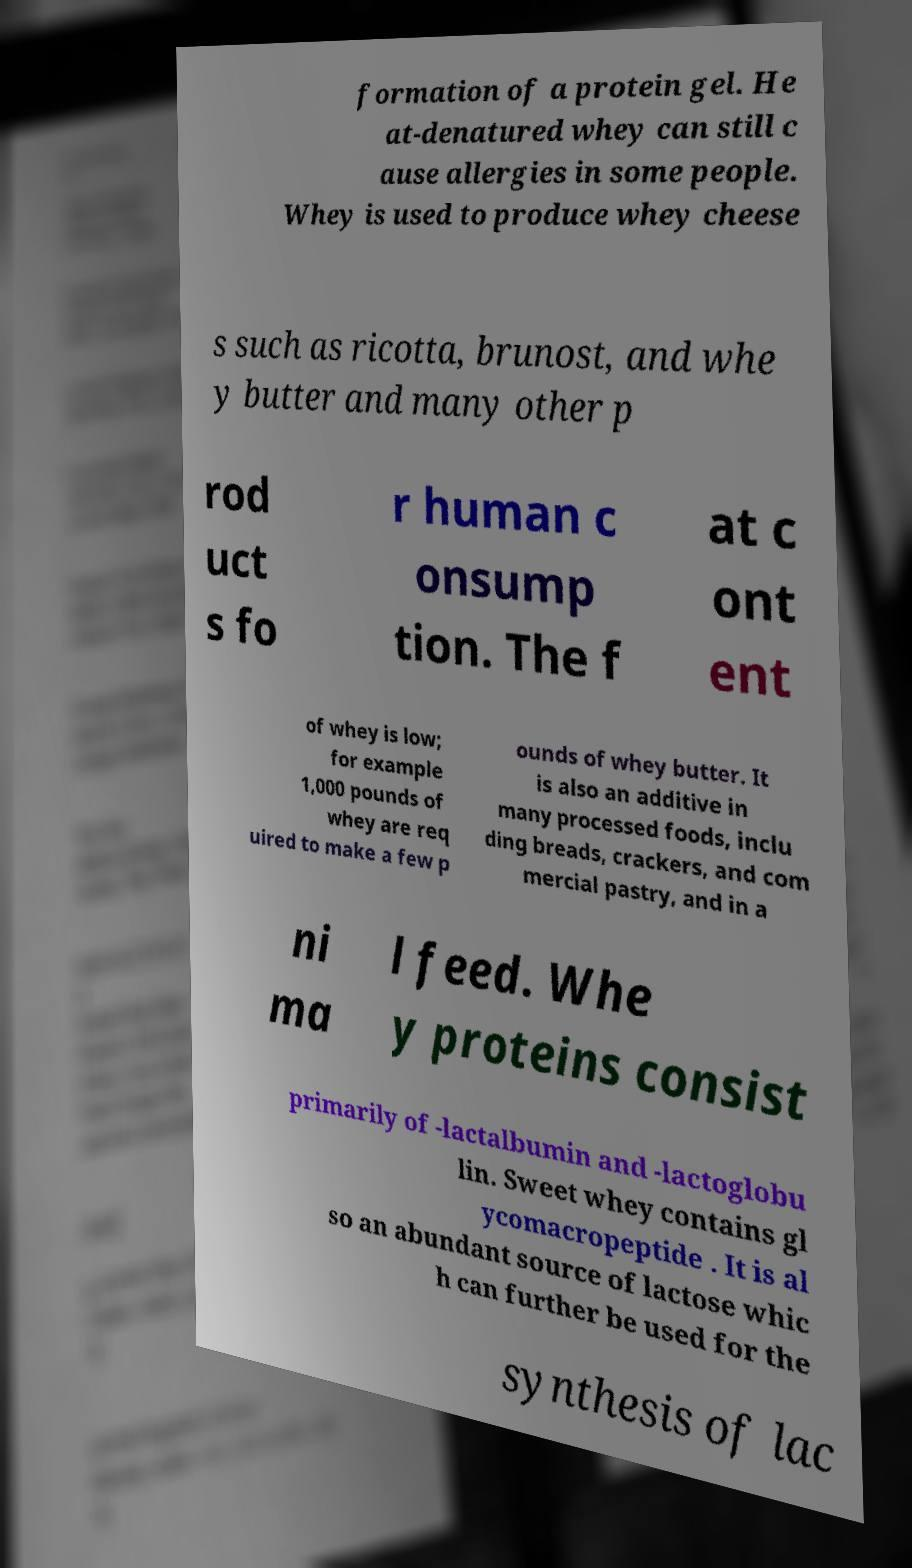Please read and relay the text visible in this image. What does it say? formation of a protein gel. He at-denatured whey can still c ause allergies in some people. Whey is used to produce whey cheese s such as ricotta, brunost, and whe y butter and many other p rod uct s fo r human c onsump tion. The f at c ont ent of whey is low; for example 1,000 pounds of whey are req uired to make a few p ounds of whey butter. It is also an additive in many processed foods, inclu ding breads, crackers, and com mercial pastry, and in a ni ma l feed. Whe y proteins consist primarily of -lactalbumin and -lactoglobu lin. Sweet whey contains gl ycomacropeptide . It is al so an abundant source of lactose whic h can further be used for the synthesis of lac 